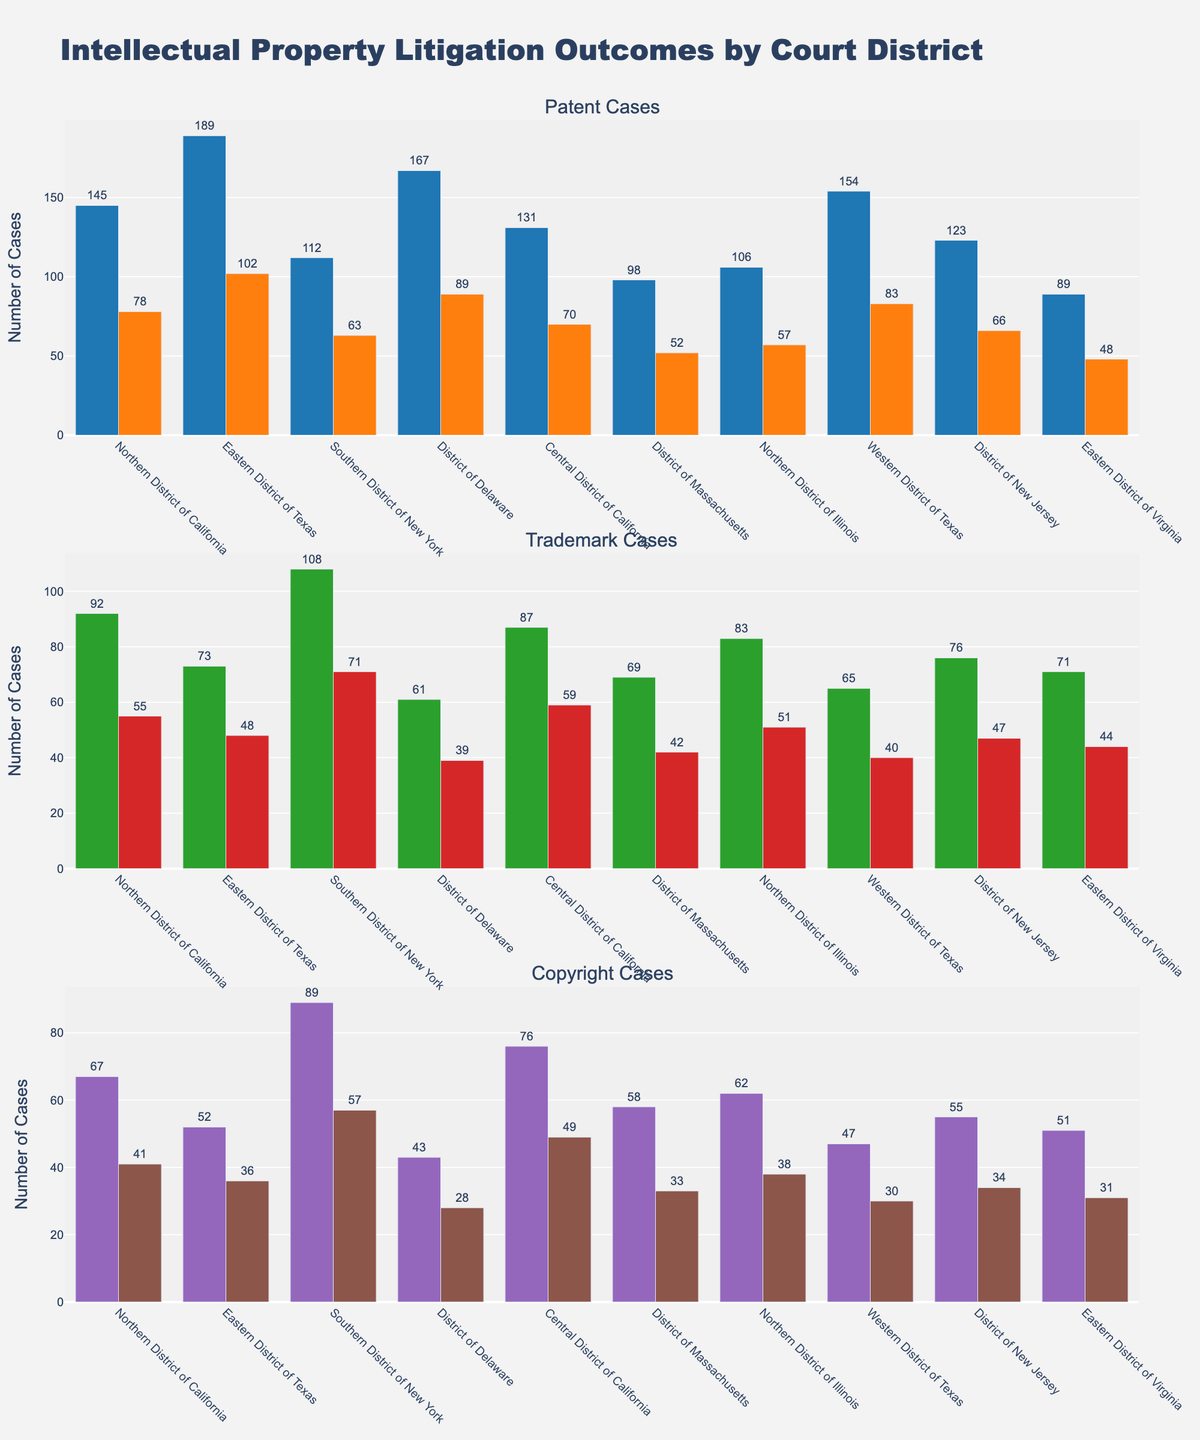What is the title of the figure? The title of a figure is typically located at the top and gives an overview of what the data represents. Here, the title displays the subject of the plots.
Answer: Intellectual Property Litigation Outcomes by Court District Which court district has the highest number of won patent cases? To find this, look at the first plot of patent cases. Identify the bar with the greatest height among those labeled as "Patent Won".
Answer: Eastern District of Texas How many total trademark cases (won + lost) were there in the Northern District of California? For this, find the bars for trademark cases in the Northern District of California in the second plot. Add the values of the won and lost trademark cases.
Answer: 147 Is there a court district where the number of lost copyright cases is equal to the number of won copyright cases? Check each district in the third plot displaying copyright cases. Look for districts where the height of the "Copyright Won" bar equals the height of the "Copyright Lost" bar.
Answer: No What is the difference between the highest and lowest number of total trademark cases (won + lost) across all court districts? Identify the district with the maximum total of trademark cases (won + lost) and the one with the minimum. Calculate the difference by subtracting the two values.
Answer: 88 Which court district has the minimum number of lost trademark cases? Look at the second plot for trademark cases. Identify the district with the shortest bar labeled as "Trademark Lost".
Answer: District of Delaware How many more copyright cases were won than lost in the Southern District of New York? For the Southern District of New York, find the bars representing won and lost copyright cases in the third plot. Subtract the value of the lost cases from the won cases.
Answer: 32 Which court district had more won copyright cases than lost in every case type? For each court district, compare the "won" and "lost" bars in all three plots (patent, trademark, and copyright). Identify the district where the "won" bars are consistently higher.
Answer: Central District of California What is the average number of won patent cases across all court districts? Sum the number of won patent cases across all districts and divide by the total number of districts.
Answer: 131.4 Which court district has the highest combined number of won cases for all types of intellectual property? For each court district, sum the won cases in all three categories (patent, trademark, copyright). Identify the district with the highest total.
Answer: Eastern District of Texas 